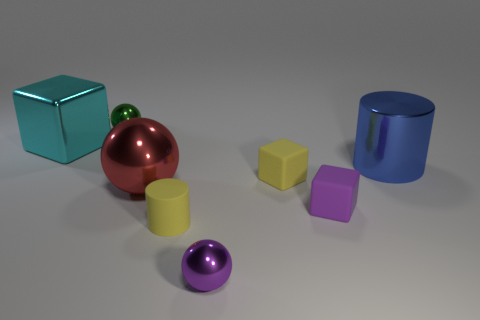Is there a cylinder that has the same size as the red thing?
Provide a succinct answer. Yes. Are the big red object and the small ball that is in front of the yellow block made of the same material?
Keep it short and to the point. Yes. Are there more purple balls than big yellow rubber cylinders?
Offer a very short reply. Yes. What number of spheres are either small cyan rubber things or shiny things?
Keep it short and to the point. 3. The large shiny block is what color?
Keep it short and to the point. Cyan. There is a yellow thing that is to the right of the purple sphere; is it the same size as the block left of the big red metallic ball?
Keep it short and to the point. No. Are there fewer tiny purple metal objects than spheres?
Offer a very short reply. Yes. There is a large red metal sphere; what number of green shiny spheres are right of it?
Give a very brief answer. 0. What material is the yellow cylinder?
Your answer should be very brief. Rubber. Is the number of large red metal things behind the cyan thing less than the number of large green metallic spheres?
Your answer should be very brief. No. 